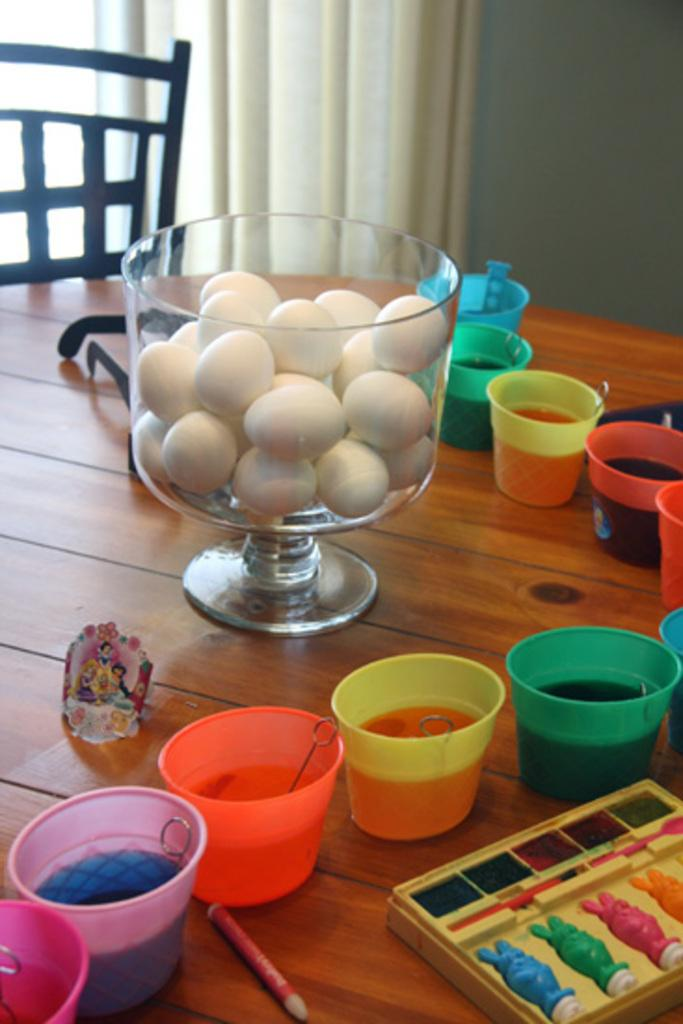What objects are on the table in the image? There are containers and eggs on the table. Are there any other items on the table besides the containers and eggs? Yes, there are other unspecified things on the table. What type of furniture is visible in the image? There is a chair in the image. What type of window treatment is present in the image? There is a curtain in the image. Can you tell me how many boots are visible in the image? There are no boots present in the image. What type of gun can be seen on the table in the image? There is no gun present in the image. 